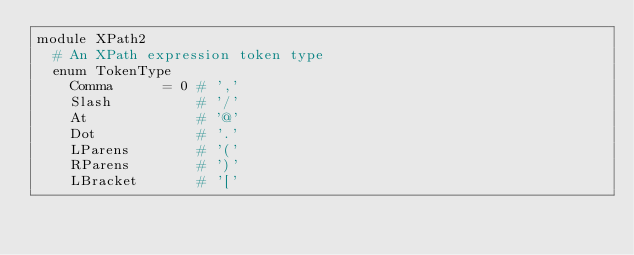Convert code to text. <code><loc_0><loc_0><loc_500><loc_500><_Crystal_>module XPath2
  # An XPath expression token type
  enum TokenType
    Comma      = 0 # ','
    Slash          # '/'
    At             # '@'
    Dot            # '.'
    LParens        # '('
    RParens        # ')'
    LBracket       # '['</code> 